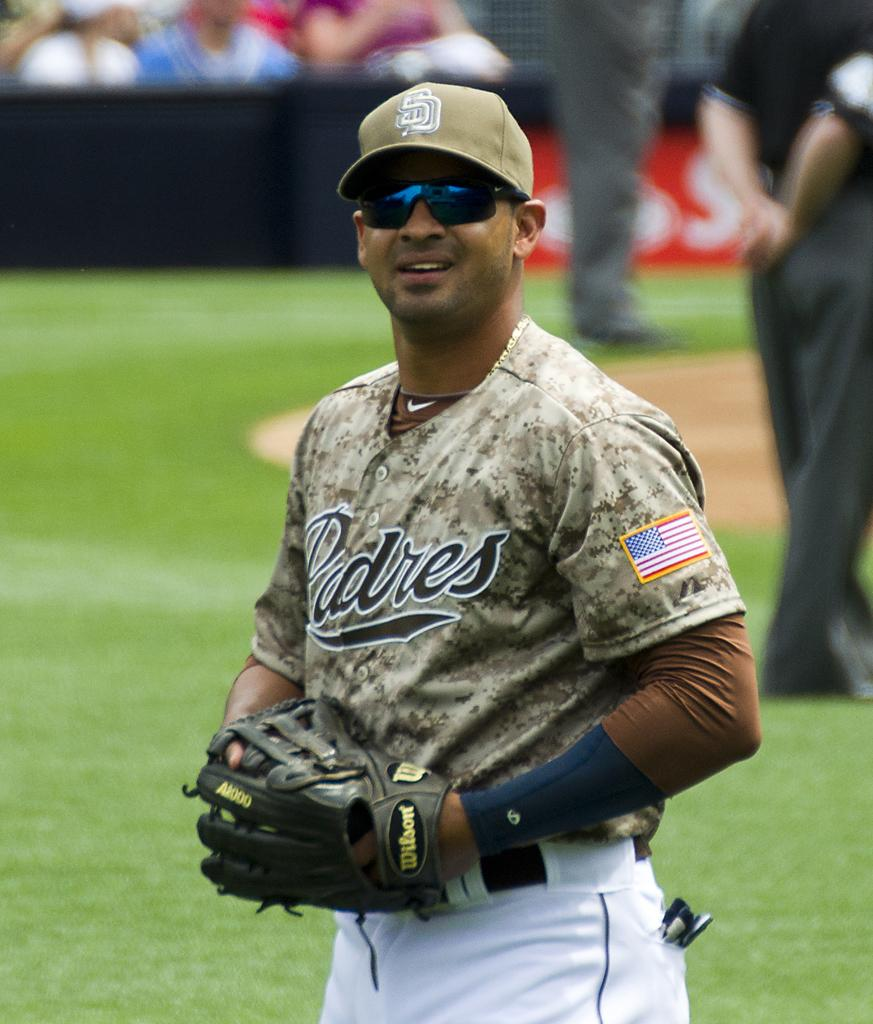<image>
Share a concise interpretation of the image provided. The pitcher for the Padres with sunglasses and in a camo jersey. 